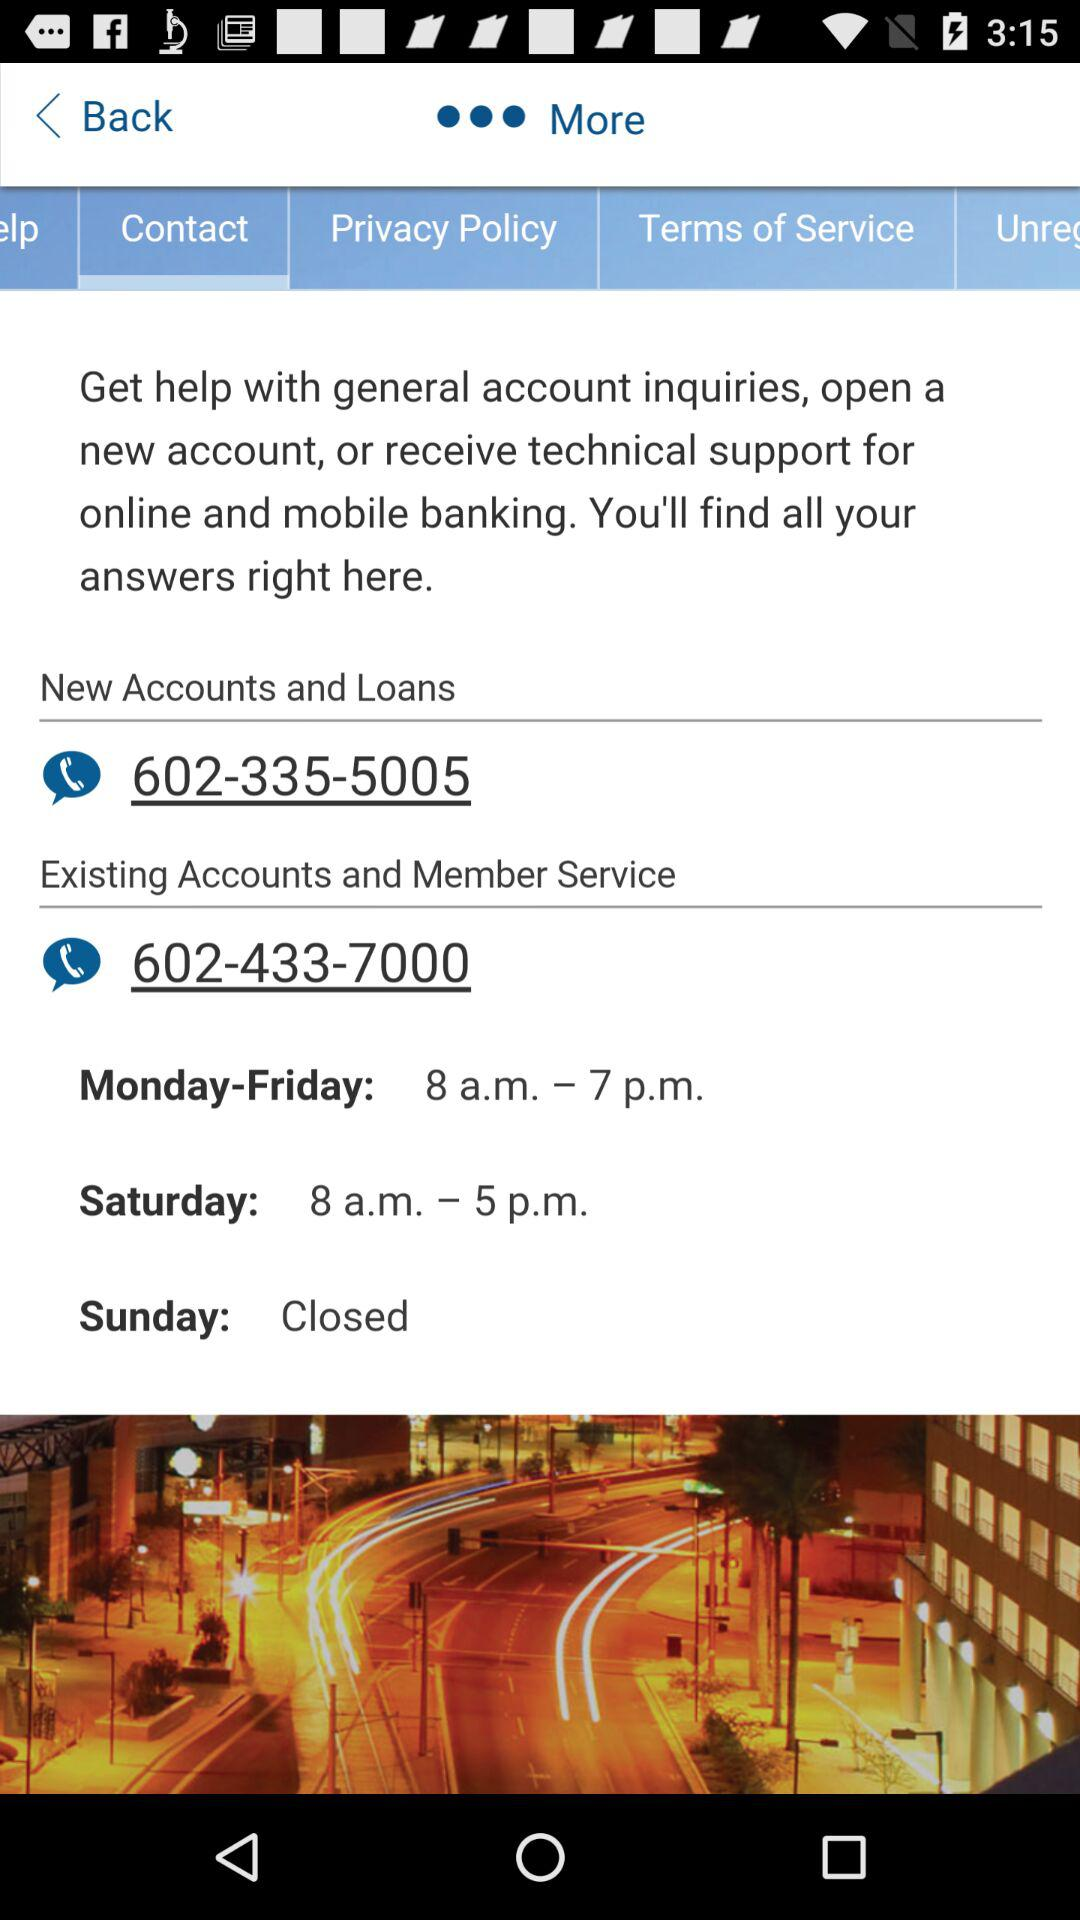What's the contact number for existing accounts and member service? The contact number for existing accounts and member service is 602-433-7000. 